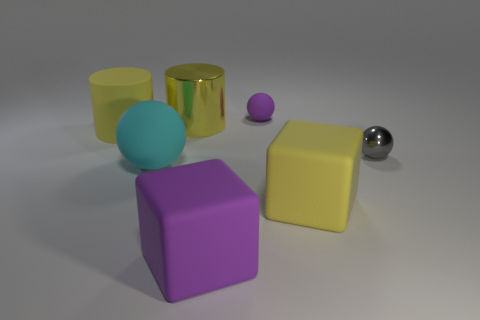Add 2 metallic cylinders. How many objects exist? 9 Subtract all balls. How many objects are left? 4 Subtract all yellow shiny cylinders. Subtract all metallic objects. How many objects are left? 4 Add 3 gray metallic balls. How many gray metallic balls are left? 4 Add 2 matte objects. How many matte objects exist? 7 Subtract 1 cyan balls. How many objects are left? 6 